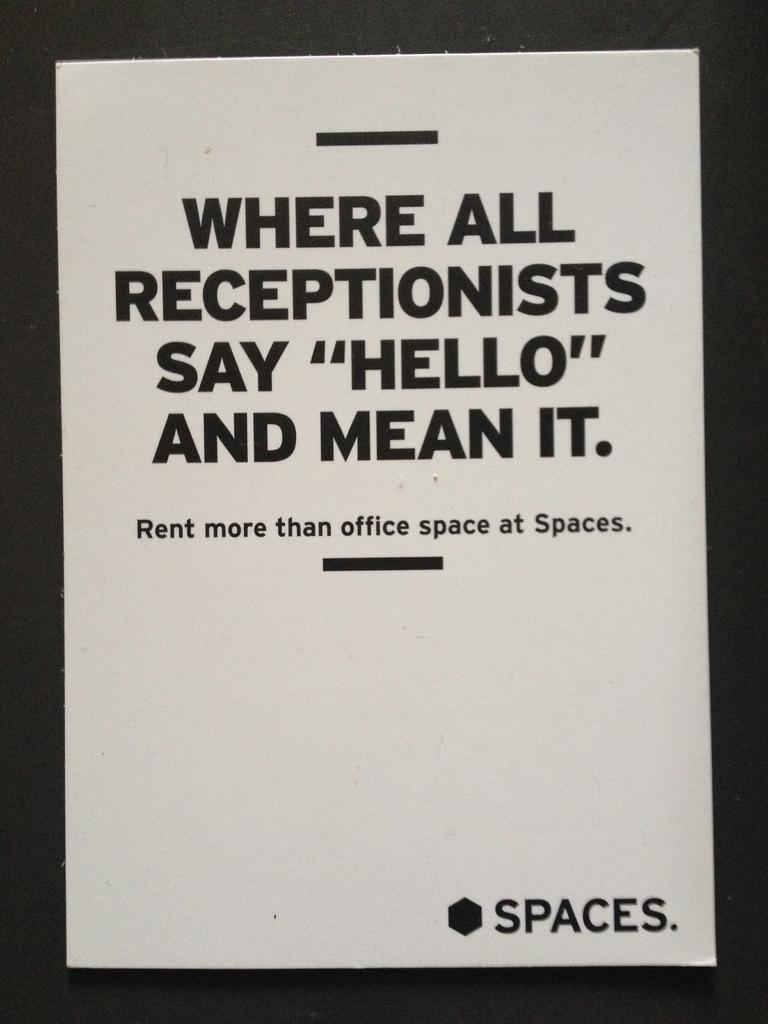Provide a one-sentence caption for the provided image. An advertisement for an office rental company called Spaces. 